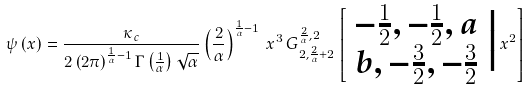<formula> <loc_0><loc_0><loc_500><loc_500>\psi \left ( x \right ) = \frac { \kappa _ { c } } { 2 \left ( 2 \pi \right ) ^ { \frac { 1 } { \alpha } - 1 } \Gamma \left ( \frac { 1 } { \alpha } \right ) \sqrt { \alpha } } \left ( \frac { 2 } { \alpha } \right ) ^ { \frac { 1 } { \alpha } - 1 } \, x ^ { 3 } \, G _ { 2 , \frac { 2 } { \alpha } + 2 } ^ { \frac { 2 } { \alpha } , 2 } \left [ \begin{array} { c } - \frac { 1 } { 2 } , - \frac { 1 } { 2 } , a \\ b , - \frac { 3 } { 2 } , - \frac { 3 } { 2 } \end{array} \Big | \, x ^ { 2 } \right ]</formula> 